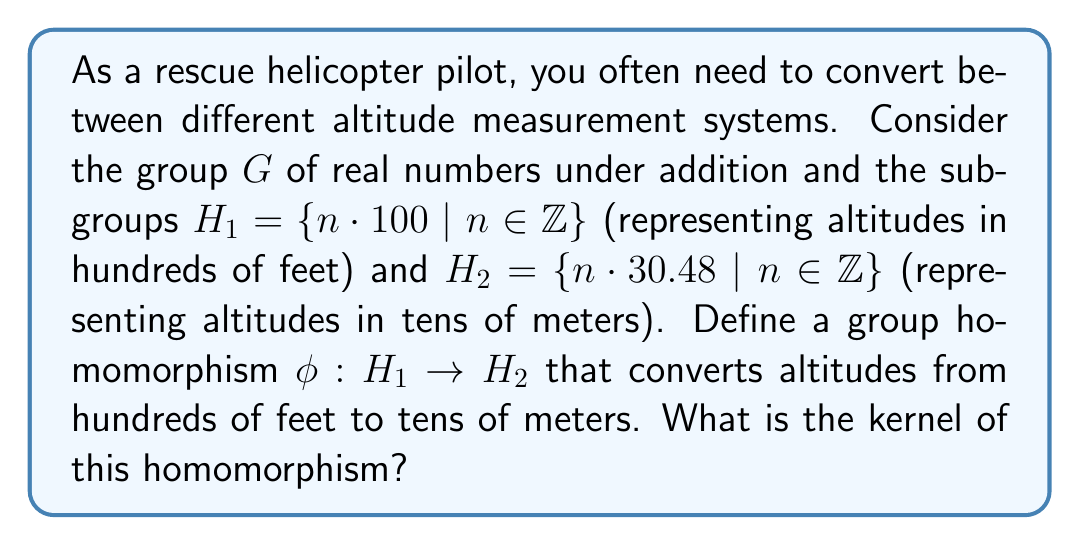Help me with this question. To solve this problem, let's follow these steps:

1) First, we need to define the homomorphism $\phi: H_1 \to H_2$. For any $h \in H_1$, we can write $h = 100n$ for some integer $n$. The corresponding altitude in meters would be $30.48n$. Therefore, we can define $\phi$ as:

   $\phi(100n) = 30.48n$ for all $n \in \mathbb{Z}$

2) To verify that this is indeed a homomorphism, we need to check that $\phi(a + b) = \phi(a) + \phi(b)$ for all $a, b \in H_1$:

   $\phi((100n) + (100m)) = \phi(100(n+m)) = 30.48(n+m) = 30.48n + 30.48m = \phi(100n) + \phi(100m)$

3) Now, to find the kernel of $\phi$, we need to find all elements $h \in H_1$ such that $\phi(h) = 0$:

   $\phi(100n) = 0$
   $30.48n = 0$
   $n = 0$

4) This means that the only element in $H_1$ that maps to 0 in $H_2$ is 0 itself.

5) Therefore, the kernel of $\phi$ is $\{0\}$.

This result is significant in the context of altitude measurements. It shows that the conversion between hundreds of feet and tens of meters is one-to-one (injective), meaning there's no loss of precision in the conversion. This is crucial for accurate navigation and risk assessment in rescue operations.
Answer: The kernel of the homomorphism $\phi$ is $\{0\}$. 